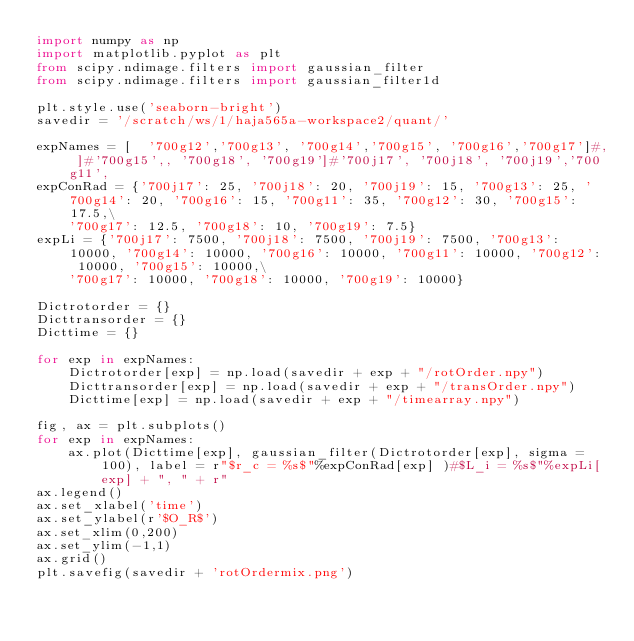Convert code to text. <code><loc_0><loc_0><loc_500><loc_500><_Python_>import numpy as np
import matplotlib.pyplot as plt
from scipy.ndimage.filters import gaussian_filter
from scipy.ndimage.filters import gaussian_filter1d

plt.style.use('seaborn-bright')
savedir = '/scratch/ws/1/haja565a-workspace2/quant/'

expNames = [  '700g12','700g13', '700g14','700g15', '700g16','700g17']#, ]#'700g15',, '700g18', '700g19']#'700j17', '700j18', '700j19','700g11',
expConRad = {'700j17': 25, '700j18': 20, '700j19': 15, '700g13': 25, '700g14': 20, '700g16': 15, '700g11': 35, '700g12': 30, '700g15': 17.5,\
    '700g17': 12.5, '700g18': 10, '700g19': 7.5}
expLi = {'700j17': 7500, '700j18': 7500, '700j19': 7500, '700g13': 10000, '700g14': 10000, '700g16': 10000, '700g11': 10000, '700g12': 10000, '700g15': 10000,\
    '700g17': 10000, '700g18': 10000, '700g19': 10000}

Dictrotorder = {}
Dicttransorder = {}
Dicttime = {}

for exp in expNames:
    Dictrotorder[exp] = np.load(savedir + exp + "/rotOrder.npy")
    Dicttransorder[exp] = np.load(savedir + exp + "/transOrder.npy")
    Dicttime[exp] = np.load(savedir + exp + "/timearray.npy")

fig, ax = plt.subplots()
for exp in expNames:
    ax.plot(Dicttime[exp], gaussian_filter(Dictrotorder[exp], sigma = 100), label = r"$r_c = %s$"%expConRad[exp] )#$L_i = %s$"%expLi[exp] + ", " + r"
ax.legend()
ax.set_xlabel('time')
ax.set_ylabel(r'$O_R$')
ax.set_xlim(0,200)
ax.set_ylim(-1,1)
ax.grid()
plt.savefig(savedir + 'rotOrdermix.png')</code> 